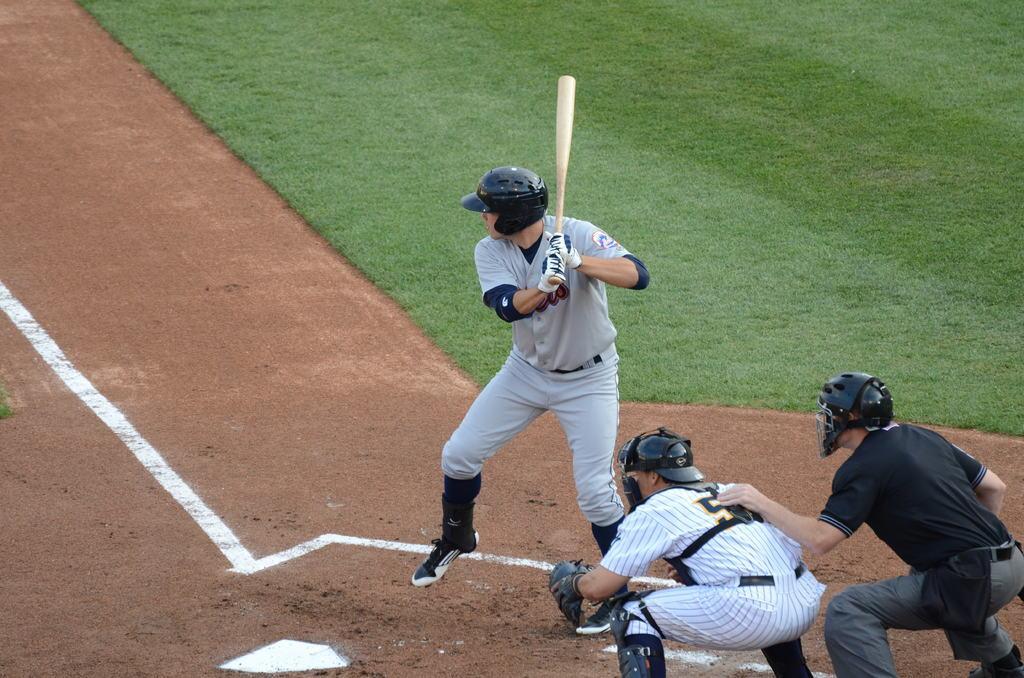Describe this image in one or two sentences. In this image in the middle there is a man, he wears a t shirt, trouser, shoes, helmet, he is holding a bat. On the right there is a man, he wears a t shirt, trouser, shoes, helmet, in front of him there is a man, he wears a t shirt, trouser, helmet. In the background there is a land and grass. 